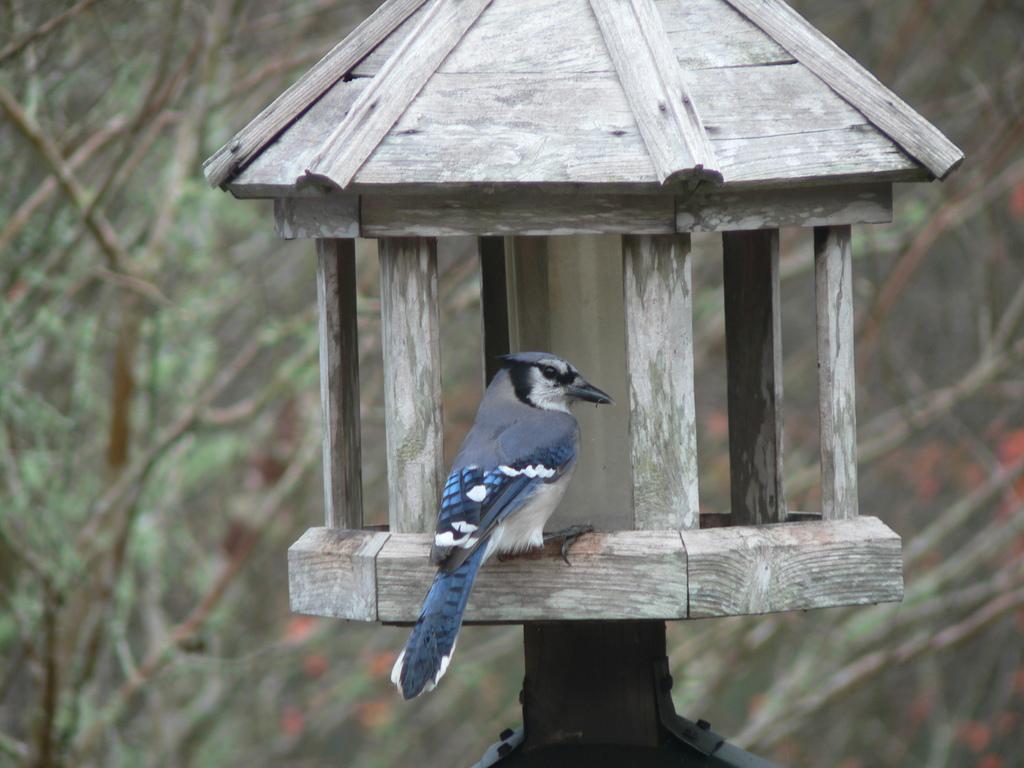Can you describe this image briefly? In this image we can see many trees. There is a lamp in the image. A bird is sitting on a wooden surface of the lamp. 